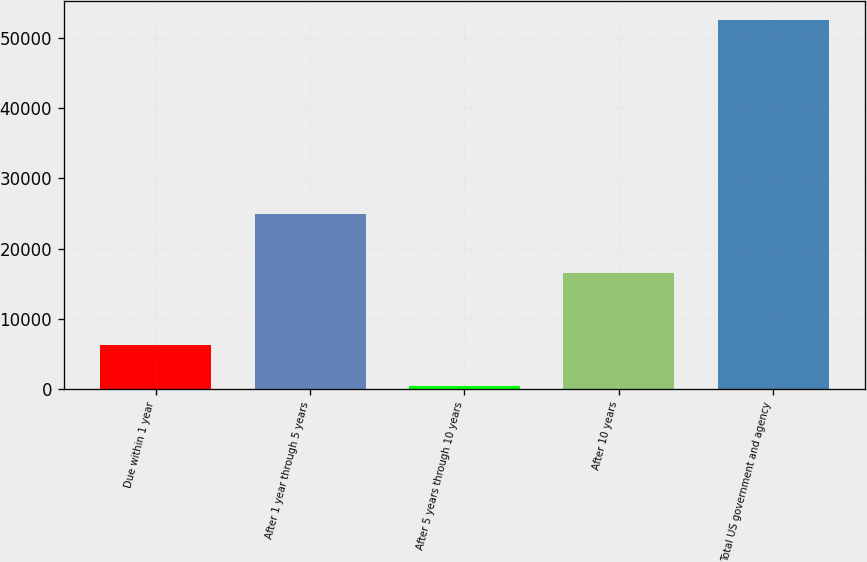Convert chart. <chart><loc_0><loc_0><loc_500><loc_500><bar_chart><fcel>Due within 1 year<fcel>After 1 year through 5 years<fcel>After 5 years through 10 years<fcel>After 10 years<fcel>Total US government and agency<nl><fcel>6209<fcel>24900<fcel>446<fcel>16465<fcel>52658<nl></chart> 